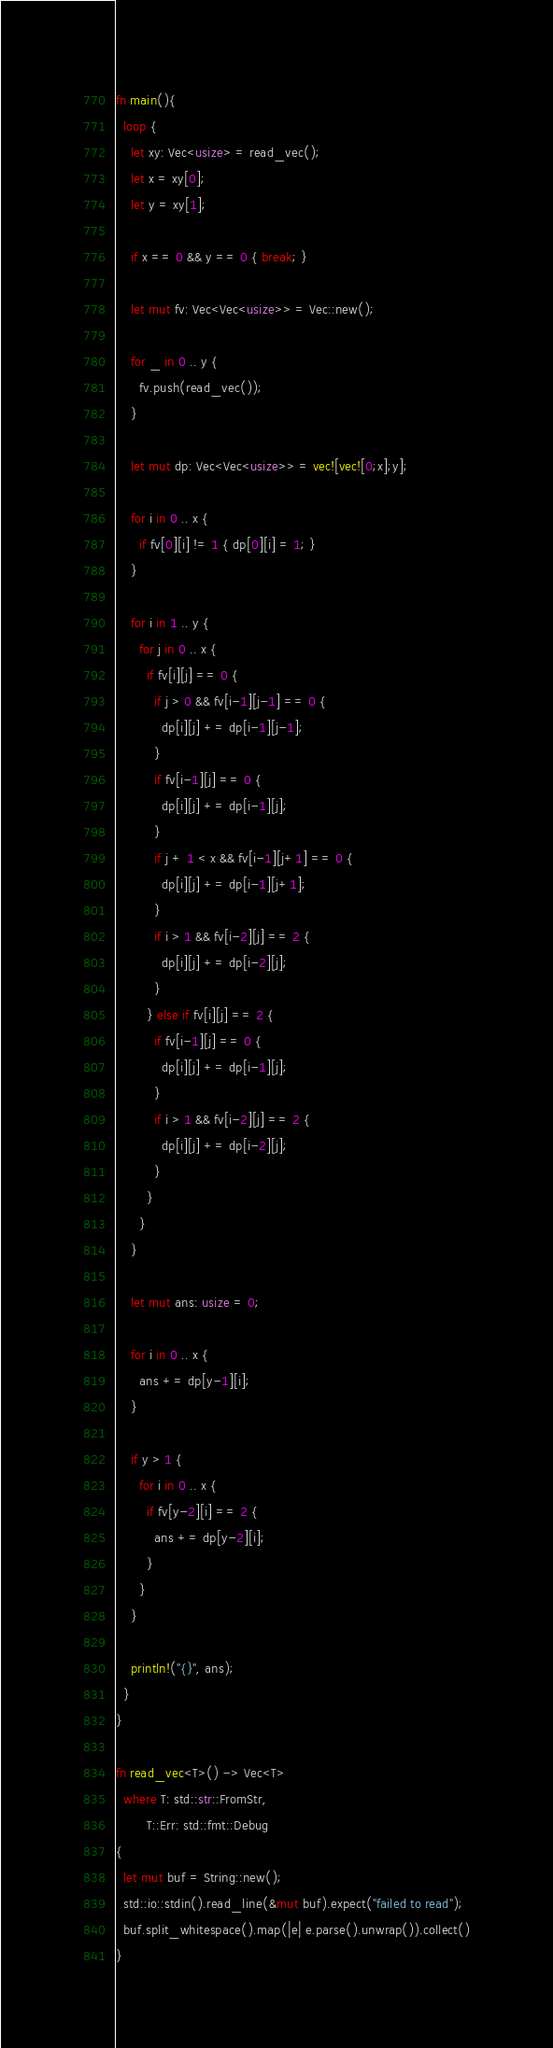<code> <loc_0><loc_0><loc_500><loc_500><_Rust_>fn main(){
  loop {
    let xy: Vec<usize> = read_vec();
    let x = xy[0];
    let y = xy[1];

    if x == 0 && y == 0 { break; }

    let mut fv: Vec<Vec<usize>> = Vec::new();

    for _ in 0 .. y {
      fv.push(read_vec());
    }
    
    let mut dp: Vec<Vec<usize>> = vec![vec![0;x];y];

    for i in 0 .. x {
      if fv[0][i] != 1 { dp[0][i] = 1; }
    }

    for i in 1 .. y {
      for j in 0 .. x {
        if fv[i][j] == 0 {
          if j > 0 && fv[i-1][j-1] == 0 {
            dp[i][j] += dp[i-1][j-1];
          }
          if fv[i-1][j] == 0 {
            dp[i][j] += dp[i-1][j];
          }
          if j + 1 < x && fv[i-1][j+1] == 0 {
            dp[i][j] += dp[i-1][j+1];
          }
          if i > 1 && fv[i-2][j] == 2 {
            dp[i][j] += dp[i-2][j];
          }
        } else if fv[i][j] == 2 {
          if fv[i-1][j] == 0 {
            dp[i][j] += dp[i-1][j];
          }
          if i > 1 && fv[i-2][j] == 2 {
            dp[i][j] += dp[i-2][j];
          }
        }
      }
    }
    
    let mut ans: usize = 0;

    for i in 0 .. x {
      ans += dp[y-1][i];
    }

    if y > 1 {
      for i in 0 .. x {
        if fv[y-2][i] == 2 {
          ans += dp[y-2][i];
        }
      }
    }

    println!("{}", ans);
  }
}

fn read_vec<T>() -> Vec<T>
  where T: std::str::FromStr,
        T::Err: std::fmt::Debug
{
  let mut buf = String::new();
  std::io::stdin().read_line(&mut buf).expect("failed to read");
  buf.split_whitespace().map(|e| e.parse().unwrap()).collect()
}

</code> 